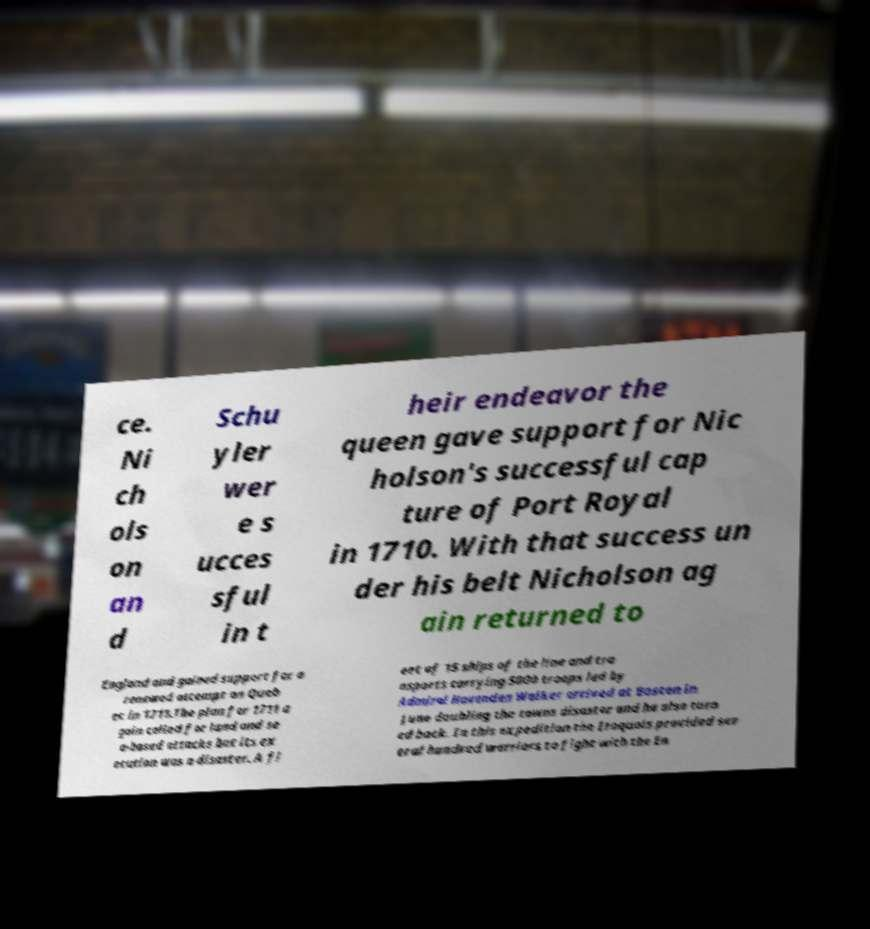Could you extract and type out the text from this image? ce. Ni ch ols on an d Schu yler wer e s ucces sful in t heir endeavor the queen gave support for Nic holson's successful cap ture of Port Royal in 1710. With that success un der his belt Nicholson ag ain returned to England and gained support for a renewed attempt on Queb ec in 1711.The plan for 1711 a gain called for land and se a-based attacks but its ex ecution was a disaster. A fl eet of 15 ships of the line and tra nsports carrying 5000 troops led by Admiral Hovenden Walker arrived at Boston in June doubling the towns disaster and he also turn ed back. In this expedition the Iroquois provided sev eral hundred warriors to fight with the En 